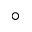Convert formula to latex. <formula><loc_0><loc_0><loc_500><loc_500>^ { \circ }</formula> 